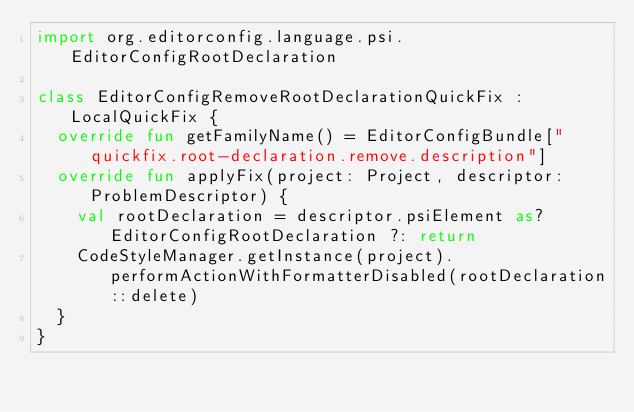Convert code to text. <code><loc_0><loc_0><loc_500><loc_500><_Kotlin_>import org.editorconfig.language.psi.EditorConfigRootDeclaration

class EditorConfigRemoveRootDeclarationQuickFix : LocalQuickFix {
  override fun getFamilyName() = EditorConfigBundle["quickfix.root-declaration.remove.description"]
  override fun applyFix(project: Project, descriptor: ProblemDescriptor) {
    val rootDeclaration = descriptor.psiElement as? EditorConfigRootDeclaration ?: return
    CodeStyleManager.getInstance(project).performActionWithFormatterDisabled(rootDeclaration::delete)
  }
}
</code> 